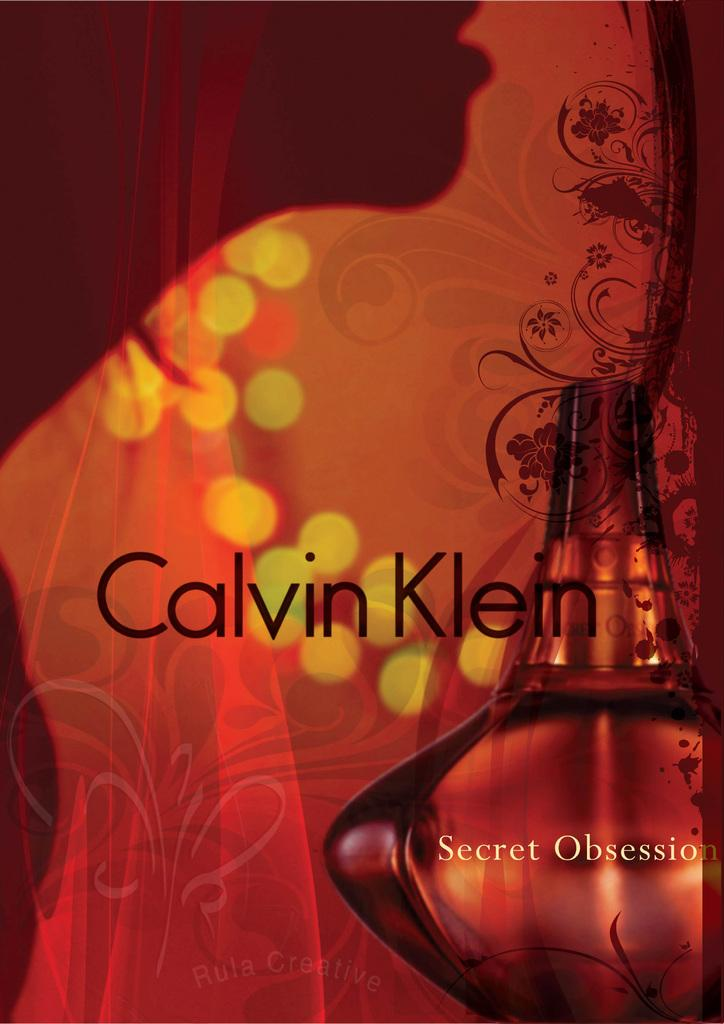<image>
Offer a succinct explanation of the picture presented. Advertisement for Secret Obsession by Calvin Klein showing a red background. 